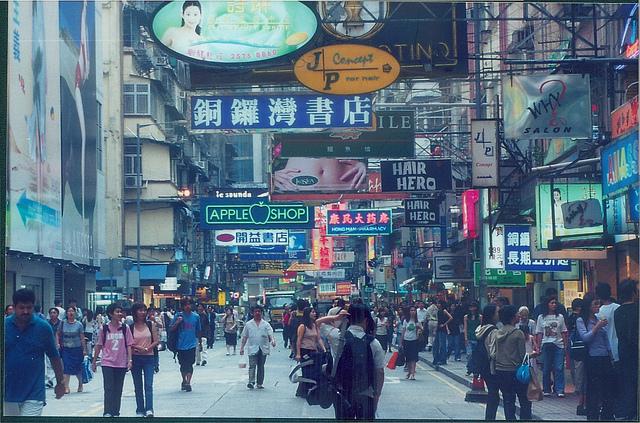In which country is this photo likely taken?
Answer briefly. China. What does the green sign say?
Short answer required. Apple shop. Are the people swimming?
Short answer required. No. What brand of watch is being advertised?
Keep it brief. Apple. 